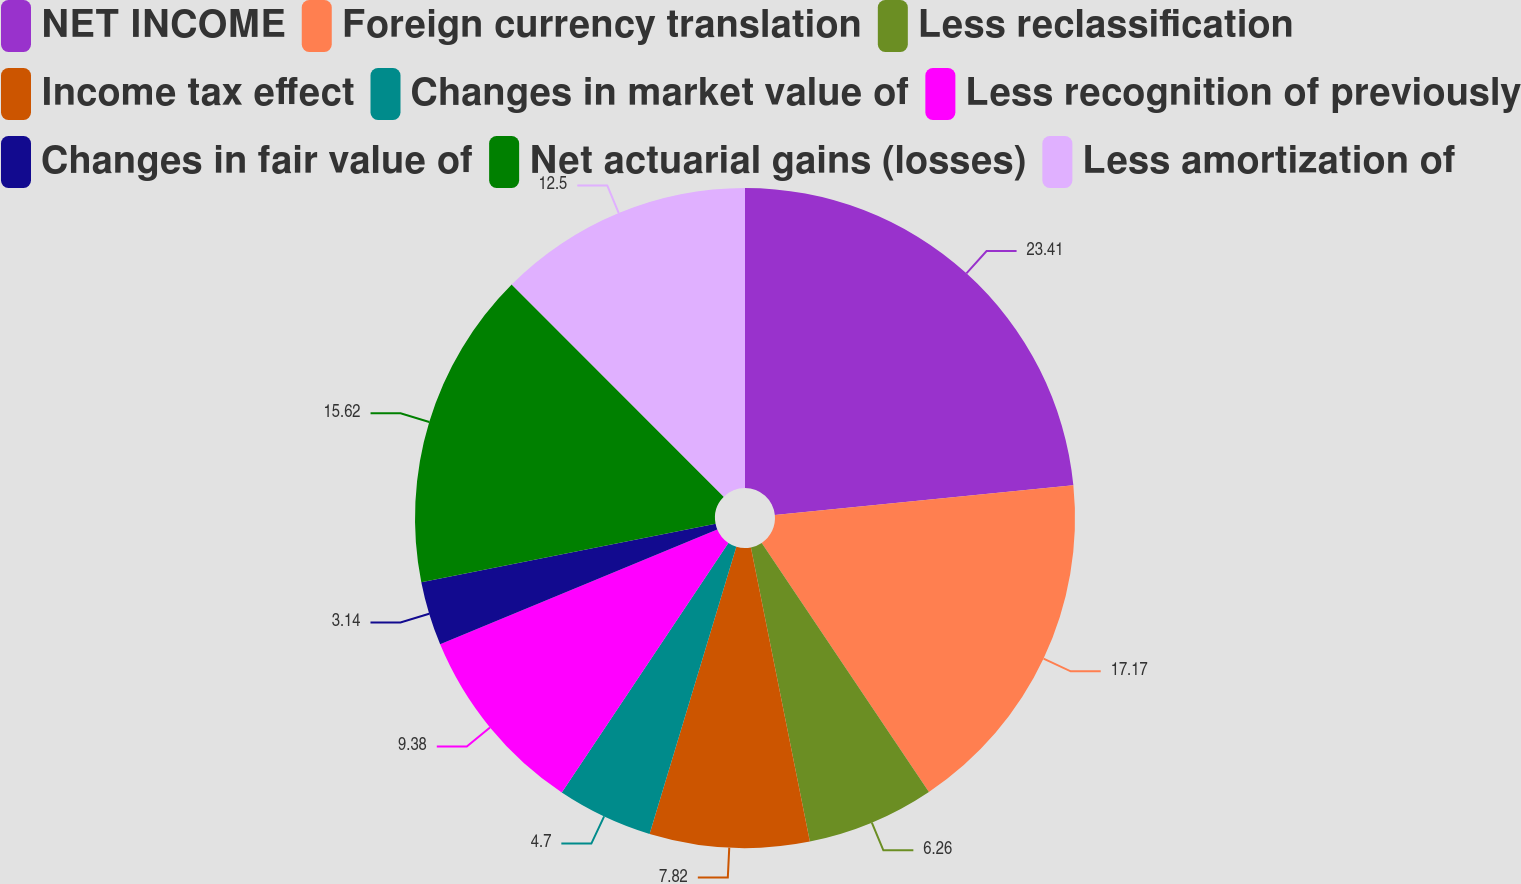Convert chart to OTSL. <chart><loc_0><loc_0><loc_500><loc_500><pie_chart><fcel>NET INCOME<fcel>Foreign currency translation<fcel>Less reclassification<fcel>Income tax effect<fcel>Changes in market value of<fcel>Less recognition of previously<fcel>Changes in fair value of<fcel>Net actuarial gains (losses)<fcel>Less amortization of<nl><fcel>23.42%<fcel>17.18%<fcel>6.26%<fcel>7.82%<fcel>4.7%<fcel>9.38%<fcel>3.14%<fcel>15.62%<fcel>12.5%<nl></chart> 